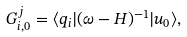<formula> <loc_0><loc_0><loc_500><loc_500>G _ { i , 0 } ^ { j } = \langle q _ { i } | ( \omega - H ) ^ { - 1 } | u _ { 0 } \rangle ,</formula> 